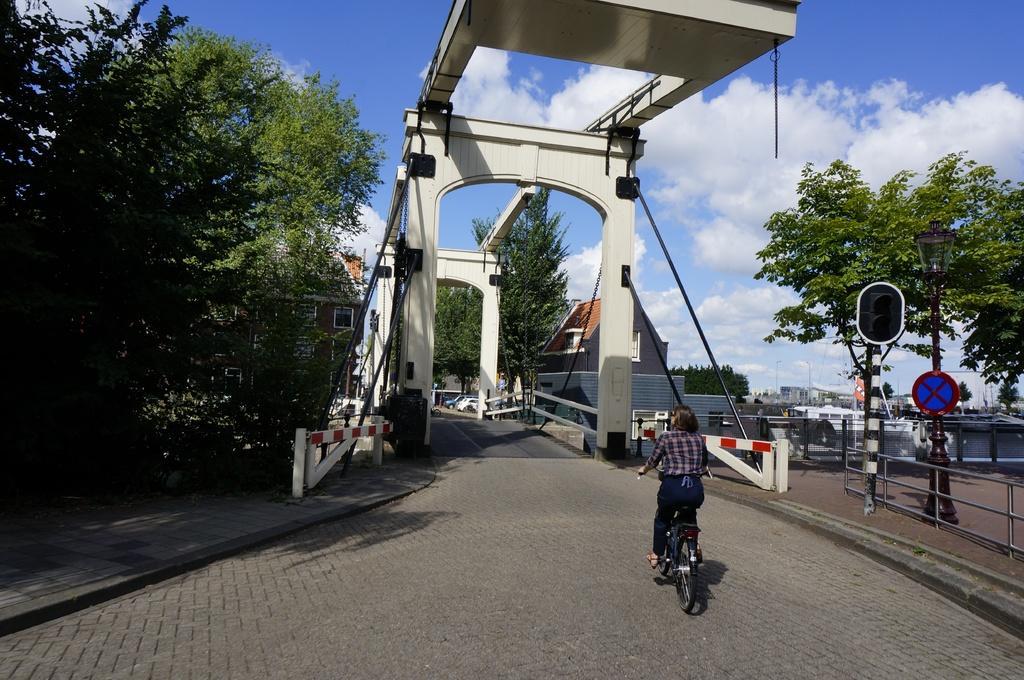Please provide a concise description of this image. In this picture I can see there is a woman riding a bicycle on to right, there is a bridge and there are trees on to left and right sides, there are buildings and there are few boats sailing on the water on to right side and the sky is clear. 